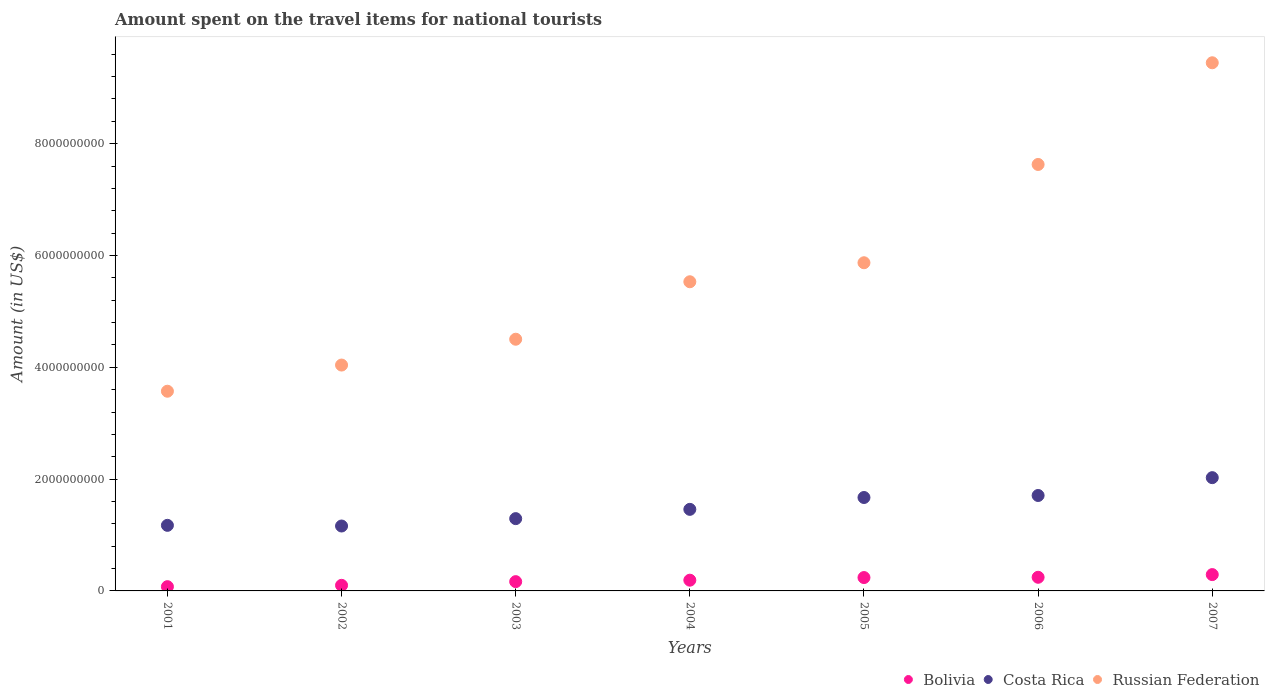Is the number of dotlines equal to the number of legend labels?
Your response must be concise. Yes. What is the amount spent on the travel items for national tourists in Costa Rica in 2004?
Ensure brevity in your answer.  1.46e+09. Across all years, what is the maximum amount spent on the travel items for national tourists in Bolivia?
Give a very brief answer. 2.92e+08. Across all years, what is the minimum amount spent on the travel items for national tourists in Costa Rica?
Give a very brief answer. 1.16e+09. In which year was the amount spent on the travel items for national tourists in Bolivia maximum?
Ensure brevity in your answer.  2007. What is the total amount spent on the travel items for national tourists in Bolivia in the graph?
Your answer should be compact. 1.31e+09. What is the difference between the amount spent on the travel items for national tourists in Russian Federation in 2003 and that in 2007?
Your answer should be compact. -4.94e+09. What is the difference between the amount spent on the travel items for national tourists in Bolivia in 2004 and the amount spent on the travel items for national tourists in Costa Rica in 2003?
Keep it short and to the point. -1.10e+09. What is the average amount spent on the travel items for national tourists in Bolivia per year?
Your answer should be compact. 1.87e+08. In the year 2004, what is the difference between the amount spent on the travel items for national tourists in Russian Federation and amount spent on the travel items for national tourists in Costa Rica?
Your response must be concise. 4.07e+09. What is the ratio of the amount spent on the travel items for national tourists in Russian Federation in 2001 to that in 2007?
Offer a very short reply. 0.38. Is the difference between the amount spent on the travel items for national tourists in Russian Federation in 2004 and 2007 greater than the difference between the amount spent on the travel items for national tourists in Costa Rica in 2004 and 2007?
Give a very brief answer. No. What is the difference between the highest and the second highest amount spent on the travel items for national tourists in Russian Federation?
Offer a very short reply. 1.82e+09. What is the difference between the highest and the lowest amount spent on the travel items for national tourists in Bolivia?
Your answer should be very brief. 2.16e+08. In how many years, is the amount spent on the travel items for national tourists in Bolivia greater than the average amount spent on the travel items for national tourists in Bolivia taken over all years?
Offer a very short reply. 4. Does the amount spent on the travel items for national tourists in Russian Federation monotonically increase over the years?
Make the answer very short. Yes. Is the amount spent on the travel items for national tourists in Russian Federation strictly greater than the amount spent on the travel items for national tourists in Costa Rica over the years?
Make the answer very short. Yes. How many years are there in the graph?
Ensure brevity in your answer.  7. Where does the legend appear in the graph?
Provide a succinct answer. Bottom right. How many legend labels are there?
Offer a terse response. 3. What is the title of the graph?
Provide a short and direct response. Amount spent on the travel items for national tourists. What is the label or title of the X-axis?
Provide a short and direct response. Years. What is the label or title of the Y-axis?
Your answer should be very brief. Amount (in US$). What is the Amount (in US$) in Bolivia in 2001?
Ensure brevity in your answer.  7.60e+07. What is the Amount (in US$) of Costa Rica in 2001?
Offer a terse response. 1.17e+09. What is the Amount (in US$) in Russian Federation in 2001?
Offer a terse response. 3.57e+09. What is the Amount (in US$) of Costa Rica in 2002?
Provide a succinct answer. 1.16e+09. What is the Amount (in US$) of Russian Federation in 2002?
Provide a short and direct response. 4.04e+09. What is the Amount (in US$) of Bolivia in 2003?
Offer a terse response. 1.66e+08. What is the Amount (in US$) of Costa Rica in 2003?
Your answer should be very brief. 1.29e+09. What is the Amount (in US$) in Russian Federation in 2003?
Offer a very short reply. 4.50e+09. What is the Amount (in US$) in Bolivia in 2004?
Ensure brevity in your answer.  1.92e+08. What is the Amount (in US$) of Costa Rica in 2004?
Offer a terse response. 1.46e+09. What is the Amount (in US$) of Russian Federation in 2004?
Ensure brevity in your answer.  5.53e+09. What is the Amount (in US$) in Bolivia in 2005?
Keep it short and to the point. 2.39e+08. What is the Amount (in US$) of Costa Rica in 2005?
Ensure brevity in your answer.  1.67e+09. What is the Amount (in US$) of Russian Federation in 2005?
Keep it short and to the point. 5.87e+09. What is the Amount (in US$) of Bolivia in 2006?
Offer a terse response. 2.44e+08. What is the Amount (in US$) of Costa Rica in 2006?
Offer a terse response. 1.71e+09. What is the Amount (in US$) in Russian Federation in 2006?
Give a very brief answer. 7.63e+09. What is the Amount (in US$) in Bolivia in 2007?
Your response must be concise. 2.92e+08. What is the Amount (in US$) of Costa Rica in 2007?
Offer a terse response. 2.03e+09. What is the Amount (in US$) of Russian Federation in 2007?
Your answer should be compact. 9.45e+09. Across all years, what is the maximum Amount (in US$) in Bolivia?
Make the answer very short. 2.92e+08. Across all years, what is the maximum Amount (in US$) of Costa Rica?
Provide a short and direct response. 2.03e+09. Across all years, what is the maximum Amount (in US$) of Russian Federation?
Make the answer very short. 9.45e+09. Across all years, what is the minimum Amount (in US$) of Bolivia?
Offer a terse response. 7.60e+07. Across all years, what is the minimum Amount (in US$) in Costa Rica?
Ensure brevity in your answer.  1.16e+09. Across all years, what is the minimum Amount (in US$) in Russian Federation?
Your answer should be very brief. 3.57e+09. What is the total Amount (in US$) in Bolivia in the graph?
Your response must be concise. 1.31e+09. What is the total Amount (in US$) of Costa Rica in the graph?
Keep it short and to the point. 1.05e+1. What is the total Amount (in US$) of Russian Federation in the graph?
Your answer should be compact. 4.06e+1. What is the difference between the Amount (in US$) in Bolivia in 2001 and that in 2002?
Provide a succinct answer. -2.40e+07. What is the difference between the Amount (in US$) in Russian Federation in 2001 and that in 2002?
Your answer should be very brief. -4.68e+08. What is the difference between the Amount (in US$) in Bolivia in 2001 and that in 2003?
Keep it short and to the point. -9.00e+07. What is the difference between the Amount (in US$) in Costa Rica in 2001 and that in 2003?
Your answer should be compact. -1.20e+08. What is the difference between the Amount (in US$) of Russian Federation in 2001 and that in 2003?
Ensure brevity in your answer.  -9.30e+08. What is the difference between the Amount (in US$) of Bolivia in 2001 and that in 2004?
Offer a very short reply. -1.16e+08. What is the difference between the Amount (in US$) of Costa Rica in 2001 and that in 2004?
Make the answer very short. -2.86e+08. What is the difference between the Amount (in US$) in Russian Federation in 2001 and that in 2004?
Give a very brief answer. -1.96e+09. What is the difference between the Amount (in US$) in Bolivia in 2001 and that in 2005?
Provide a short and direct response. -1.63e+08. What is the difference between the Amount (in US$) of Costa Rica in 2001 and that in 2005?
Give a very brief answer. -4.98e+08. What is the difference between the Amount (in US$) of Russian Federation in 2001 and that in 2005?
Ensure brevity in your answer.  -2.30e+09. What is the difference between the Amount (in US$) in Bolivia in 2001 and that in 2006?
Offer a terse response. -1.68e+08. What is the difference between the Amount (in US$) in Costa Rica in 2001 and that in 2006?
Your answer should be very brief. -5.34e+08. What is the difference between the Amount (in US$) in Russian Federation in 2001 and that in 2006?
Make the answer very short. -4.06e+09. What is the difference between the Amount (in US$) of Bolivia in 2001 and that in 2007?
Provide a short and direct response. -2.16e+08. What is the difference between the Amount (in US$) in Costa Rica in 2001 and that in 2007?
Offer a very short reply. -8.53e+08. What is the difference between the Amount (in US$) of Russian Federation in 2001 and that in 2007?
Provide a succinct answer. -5.88e+09. What is the difference between the Amount (in US$) in Bolivia in 2002 and that in 2003?
Make the answer very short. -6.60e+07. What is the difference between the Amount (in US$) in Costa Rica in 2002 and that in 2003?
Provide a succinct answer. -1.32e+08. What is the difference between the Amount (in US$) of Russian Federation in 2002 and that in 2003?
Your response must be concise. -4.62e+08. What is the difference between the Amount (in US$) of Bolivia in 2002 and that in 2004?
Your answer should be very brief. -9.20e+07. What is the difference between the Amount (in US$) in Costa Rica in 2002 and that in 2004?
Ensure brevity in your answer.  -2.98e+08. What is the difference between the Amount (in US$) of Russian Federation in 2002 and that in 2004?
Keep it short and to the point. -1.49e+09. What is the difference between the Amount (in US$) of Bolivia in 2002 and that in 2005?
Keep it short and to the point. -1.39e+08. What is the difference between the Amount (in US$) in Costa Rica in 2002 and that in 2005?
Offer a terse response. -5.10e+08. What is the difference between the Amount (in US$) in Russian Federation in 2002 and that in 2005?
Your answer should be compact. -1.83e+09. What is the difference between the Amount (in US$) in Bolivia in 2002 and that in 2006?
Your response must be concise. -1.44e+08. What is the difference between the Amount (in US$) of Costa Rica in 2002 and that in 2006?
Provide a succinct answer. -5.46e+08. What is the difference between the Amount (in US$) of Russian Federation in 2002 and that in 2006?
Make the answer very short. -3.59e+09. What is the difference between the Amount (in US$) of Bolivia in 2002 and that in 2007?
Provide a short and direct response. -1.92e+08. What is the difference between the Amount (in US$) in Costa Rica in 2002 and that in 2007?
Offer a very short reply. -8.65e+08. What is the difference between the Amount (in US$) of Russian Federation in 2002 and that in 2007?
Ensure brevity in your answer.  -5.41e+09. What is the difference between the Amount (in US$) of Bolivia in 2003 and that in 2004?
Provide a succinct answer. -2.60e+07. What is the difference between the Amount (in US$) in Costa Rica in 2003 and that in 2004?
Your answer should be very brief. -1.66e+08. What is the difference between the Amount (in US$) in Russian Federation in 2003 and that in 2004?
Offer a very short reply. -1.03e+09. What is the difference between the Amount (in US$) of Bolivia in 2003 and that in 2005?
Your answer should be compact. -7.30e+07. What is the difference between the Amount (in US$) in Costa Rica in 2003 and that in 2005?
Keep it short and to the point. -3.78e+08. What is the difference between the Amount (in US$) of Russian Federation in 2003 and that in 2005?
Give a very brief answer. -1.37e+09. What is the difference between the Amount (in US$) of Bolivia in 2003 and that in 2006?
Your answer should be compact. -7.80e+07. What is the difference between the Amount (in US$) of Costa Rica in 2003 and that in 2006?
Offer a terse response. -4.14e+08. What is the difference between the Amount (in US$) in Russian Federation in 2003 and that in 2006?
Make the answer very short. -3.13e+09. What is the difference between the Amount (in US$) of Bolivia in 2003 and that in 2007?
Offer a very short reply. -1.26e+08. What is the difference between the Amount (in US$) in Costa Rica in 2003 and that in 2007?
Give a very brief answer. -7.33e+08. What is the difference between the Amount (in US$) in Russian Federation in 2003 and that in 2007?
Your response must be concise. -4.94e+09. What is the difference between the Amount (in US$) of Bolivia in 2004 and that in 2005?
Ensure brevity in your answer.  -4.70e+07. What is the difference between the Amount (in US$) of Costa Rica in 2004 and that in 2005?
Provide a succinct answer. -2.12e+08. What is the difference between the Amount (in US$) in Russian Federation in 2004 and that in 2005?
Keep it short and to the point. -3.40e+08. What is the difference between the Amount (in US$) in Bolivia in 2004 and that in 2006?
Your answer should be very brief. -5.20e+07. What is the difference between the Amount (in US$) of Costa Rica in 2004 and that in 2006?
Provide a succinct answer. -2.48e+08. What is the difference between the Amount (in US$) of Russian Federation in 2004 and that in 2006?
Keep it short and to the point. -2.10e+09. What is the difference between the Amount (in US$) in Bolivia in 2004 and that in 2007?
Provide a succinct answer. -1.00e+08. What is the difference between the Amount (in US$) of Costa Rica in 2004 and that in 2007?
Your response must be concise. -5.67e+08. What is the difference between the Amount (in US$) of Russian Federation in 2004 and that in 2007?
Give a very brief answer. -3.92e+09. What is the difference between the Amount (in US$) in Bolivia in 2005 and that in 2006?
Offer a terse response. -5.00e+06. What is the difference between the Amount (in US$) of Costa Rica in 2005 and that in 2006?
Provide a succinct answer. -3.60e+07. What is the difference between the Amount (in US$) of Russian Federation in 2005 and that in 2006?
Keep it short and to the point. -1.76e+09. What is the difference between the Amount (in US$) of Bolivia in 2005 and that in 2007?
Ensure brevity in your answer.  -5.30e+07. What is the difference between the Amount (in US$) in Costa Rica in 2005 and that in 2007?
Ensure brevity in your answer.  -3.55e+08. What is the difference between the Amount (in US$) in Russian Federation in 2005 and that in 2007?
Your answer should be very brief. -3.58e+09. What is the difference between the Amount (in US$) in Bolivia in 2006 and that in 2007?
Ensure brevity in your answer.  -4.80e+07. What is the difference between the Amount (in US$) of Costa Rica in 2006 and that in 2007?
Provide a short and direct response. -3.19e+08. What is the difference between the Amount (in US$) in Russian Federation in 2006 and that in 2007?
Give a very brief answer. -1.82e+09. What is the difference between the Amount (in US$) of Bolivia in 2001 and the Amount (in US$) of Costa Rica in 2002?
Keep it short and to the point. -1.08e+09. What is the difference between the Amount (in US$) in Bolivia in 2001 and the Amount (in US$) in Russian Federation in 2002?
Offer a very short reply. -3.96e+09. What is the difference between the Amount (in US$) in Costa Rica in 2001 and the Amount (in US$) in Russian Federation in 2002?
Your answer should be compact. -2.87e+09. What is the difference between the Amount (in US$) of Bolivia in 2001 and the Amount (in US$) of Costa Rica in 2003?
Your answer should be compact. -1.22e+09. What is the difference between the Amount (in US$) of Bolivia in 2001 and the Amount (in US$) of Russian Federation in 2003?
Offer a terse response. -4.43e+09. What is the difference between the Amount (in US$) of Costa Rica in 2001 and the Amount (in US$) of Russian Federation in 2003?
Make the answer very short. -3.33e+09. What is the difference between the Amount (in US$) of Bolivia in 2001 and the Amount (in US$) of Costa Rica in 2004?
Provide a short and direct response. -1.38e+09. What is the difference between the Amount (in US$) in Bolivia in 2001 and the Amount (in US$) in Russian Federation in 2004?
Offer a very short reply. -5.45e+09. What is the difference between the Amount (in US$) in Costa Rica in 2001 and the Amount (in US$) in Russian Federation in 2004?
Offer a very short reply. -4.36e+09. What is the difference between the Amount (in US$) in Bolivia in 2001 and the Amount (in US$) in Costa Rica in 2005?
Give a very brief answer. -1.60e+09. What is the difference between the Amount (in US$) of Bolivia in 2001 and the Amount (in US$) of Russian Federation in 2005?
Ensure brevity in your answer.  -5.79e+09. What is the difference between the Amount (in US$) in Costa Rica in 2001 and the Amount (in US$) in Russian Federation in 2005?
Your answer should be compact. -4.70e+09. What is the difference between the Amount (in US$) of Bolivia in 2001 and the Amount (in US$) of Costa Rica in 2006?
Make the answer very short. -1.63e+09. What is the difference between the Amount (in US$) in Bolivia in 2001 and the Amount (in US$) in Russian Federation in 2006?
Give a very brief answer. -7.55e+09. What is the difference between the Amount (in US$) of Costa Rica in 2001 and the Amount (in US$) of Russian Federation in 2006?
Give a very brief answer. -6.46e+09. What is the difference between the Amount (in US$) of Bolivia in 2001 and the Amount (in US$) of Costa Rica in 2007?
Offer a terse response. -1.95e+09. What is the difference between the Amount (in US$) in Bolivia in 2001 and the Amount (in US$) in Russian Federation in 2007?
Make the answer very short. -9.37e+09. What is the difference between the Amount (in US$) of Costa Rica in 2001 and the Amount (in US$) of Russian Federation in 2007?
Give a very brief answer. -8.27e+09. What is the difference between the Amount (in US$) of Bolivia in 2002 and the Amount (in US$) of Costa Rica in 2003?
Give a very brief answer. -1.19e+09. What is the difference between the Amount (in US$) in Bolivia in 2002 and the Amount (in US$) in Russian Federation in 2003?
Give a very brief answer. -4.40e+09. What is the difference between the Amount (in US$) in Costa Rica in 2002 and the Amount (in US$) in Russian Federation in 2003?
Offer a terse response. -3.34e+09. What is the difference between the Amount (in US$) in Bolivia in 2002 and the Amount (in US$) in Costa Rica in 2004?
Offer a very short reply. -1.36e+09. What is the difference between the Amount (in US$) in Bolivia in 2002 and the Amount (in US$) in Russian Federation in 2004?
Ensure brevity in your answer.  -5.43e+09. What is the difference between the Amount (in US$) in Costa Rica in 2002 and the Amount (in US$) in Russian Federation in 2004?
Keep it short and to the point. -4.37e+09. What is the difference between the Amount (in US$) in Bolivia in 2002 and the Amount (in US$) in Costa Rica in 2005?
Your answer should be compact. -1.57e+09. What is the difference between the Amount (in US$) in Bolivia in 2002 and the Amount (in US$) in Russian Federation in 2005?
Your response must be concise. -5.77e+09. What is the difference between the Amount (in US$) of Costa Rica in 2002 and the Amount (in US$) of Russian Federation in 2005?
Provide a succinct answer. -4.71e+09. What is the difference between the Amount (in US$) of Bolivia in 2002 and the Amount (in US$) of Costa Rica in 2006?
Your response must be concise. -1.61e+09. What is the difference between the Amount (in US$) in Bolivia in 2002 and the Amount (in US$) in Russian Federation in 2006?
Provide a succinct answer. -7.53e+09. What is the difference between the Amount (in US$) of Costa Rica in 2002 and the Amount (in US$) of Russian Federation in 2006?
Make the answer very short. -6.47e+09. What is the difference between the Amount (in US$) in Bolivia in 2002 and the Amount (in US$) in Costa Rica in 2007?
Your response must be concise. -1.93e+09. What is the difference between the Amount (in US$) of Bolivia in 2002 and the Amount (in US$) of Russian Federation in 2007?
Your answer should be very brief. -9.35e+09. What is the difference between the Amount (in US$) in Costa Rica in 2002 and the Amount (in US$) in Russian Federation in 2007?
Your answer should be very brief. -8.29e+09. What is the difference between the Amount (in US$) in Bolivia in 2003 and the Amount (in US$) in Costa Rica in 2004?
Your answer should be very brief. -1.29e+09. What is the difference between the Amount (in US$) of Bolivia in 2003 and the Amount (in US$) of Russian Federation in 2004?
Offer a very short reply. -5.36e+09. What is the difference between the Amount (in US$) in Costa Rica in 2003 and the Amount (in US$) in Russian Federation in 2004?
Provide a succinct answer. -4.24e+09. What is the difference between the Amount (in US$) in Bolivia in 2003 and the Amount (in US$) in Costa Rica in 2005?
Your answer should be very brief. -1.50e+09. What is the difference between the Amount (in US$) of Bolivia in 2003 and the Amount (in US$) of Russian Federation in 2005?
Provide a succinct answer. -5.70e+09. What is the difference between the Amount (in US$) of Costa Rica in 2003 and the Amount (in US$) of Russian Federation in 2005?
Give a very brief answer. -4.58e+09. What is the difference between the Amount (in US$) of Bolivia in 2003 and the Amount (in US$) of Costa Rica in 2006?
Give a very brief answer. -1.54e+09. What is the difference between the Amount (in US$) of Bolivia in 2003 and the Amount (in US$) of Russian Federation in 2006?
Give a very brief answer. -7.46e+09. What is the difference between the Amount (in US$) of Costa Rica in 2003 and the Amount (in US$) of Russian Federation in 2006?
Your response must be concise. -6.34e+09. What is the difference between the Amount (in US$) of Bolivia in 2003 and the Amount (in US$) of Costa Rica in 2007?
Provide a succinct answer. -1.86e+09. What is the difference between the Amount (in US$) of Bolivia in 2003 and the Amount (in US$) of Russian Federation in 2007?
Provide a short and direct response. -9.28e+09. What is the difference between the Amount (in US$) of Costa Rica in 2003 and the Amount (in US$) of Russian Federation in 2007?
Your response must be concise. -8.15e+09. What is the difference between the Amount (in US$) of Bolivia in 2004 and the Amount (in US$) of Costa Rica in 2005?
Make the answer very short. -1.48e+09. What is the difference between the Amount (in US$) in Bolivia in 2004 and the Amount (in US$) in Russian Federation in 2005?
Your answer should be very brief. -5.68e+09. What is the difference between the Amount (in US$) in Costa Rica in 2004 and the Amount (in US$) in Russian Federation in 2005?
Your answer should be very brief. -4.41e+09. What is the difference between the Amount (in US$) of Bolivia in 2004 and the Amount (in US$) of Costa Rica in 2006?
Offer a very short reply. -1.52e+09. What is the difference between the Amount (in US$) in Bolivia in 2004 and the Amount (in US$) in Russian Federation in 2006?
Provide a succinct answer. -7.44e+09. What is the difference between the Amount (in US$) in Costa Rica in 2004 and the Amount (in US$) in Russian Federation in 2006?
Your answer should be very brief. -6.17e+09. What is the difference between the Amount (in US$) in Bolivia in 2004 and the Amount (in US$) in Costa Rica in 2007?
Keep it short and to the point. -1.83e+09. What is the difference between the Amount (in US$) of Bolivia in 2004 and the Amount (in US$) of Russian Federation in 2007?
Keep it short and to the point. -9.26e+09. What is the difference between the Amount (in US$) of Costa Rica in 2004 and the Amount (in US$) of Russian Federation in 2007?
Offer a very short reply. -7.99e+09. What is the difference between the Amount (in US$) of Bolivia in 2005 and the Amount (in US$) of Costa Rica in 2006?
Provide a short and direct response. -1.47e+09. What is the difference between the Amount (in US$) in Bolivia in 2005 and the Amount (in US$) in Russian Federation in 2006?
Give a very brief answer. -7.39e+09. What is the difference between the Amount (in US$) in Costa Rica in 2005 and the Amount (in US$) in Russian Federation in 2006?
Make the answer very short. -5.96e+09. What is the difference between the Amount (in US$) in Bolivia in 2005 and the Amount (in US$) in Costa Rica in 2007?
Your response must be concise. -1.79e+09. What is the difference between the Amount (in US$) in Bolivia in 2005 and the Amount (in US$) in Russian Federation in 2007?
Make the answer very short. -9.21e+09. What is the difference between the Amount (in US$) in Costa Rica in 2005 and the Amount (in US$) in Russian Federation in 2007?
Provide a short and direct response. -7.78e+09. What is the difference between the Amount (in US$) in Bolivia in 2006 and the Amount (in US$) in Costa Rica in 2007?
Ensure brevity in your answer.  -1.78e+09. What is the difference between the Amount (in US$) of Bolivia in 2006 and the Amount (in US$) of Russian Federation in 2007?
Provide a short and direct response. -9.20e+09. What is the difference between the Amount (in US$) of Costa Rica in 2006 and the Amount (in US$) of Russian Federation in 2007?
Your answer should be compact. -7.74e+09. What is the average Amount (in US$) in Bolivia per year?
Your response must be concise. 1.87e+08. What is the average Amount (in US$) of Costa Rica per year?
Offer a terse response. 1.50e+09. What is the average Amount (in US$) of Russian Federation per year?
Your answer should be very brief. 5.80e+09. In the year 2001, what is the difference between the Amount (in US$) of Bolivia and Amount (in US$) of Costa Rica?
Your answer should be compact. -1.10e+09. In the year 2001, what is the difference between the Amount (in US$) in Bolivia and Amount (in US$) in Russian Federation?
Provide a short and direct response. -3.50e+09. In the year 2001, what is the difference between the Amount (in US$) of Costa Rica and Amount (in US$) of Russian Federation?
Keep it short and to the point. -2.40e+09. In the year 2002, what is the difference between the Amount (in US$) of Bolivia and Amount (in US$) of Costa Rica?
Your response must be concise. -1.06e+09. In the year 2002, what is the difference between the Amount (in US$) in Bolivia and Amount (in US$) in Russian Federation?
Offer a terse response. -3.94e+09. In the year 2002, what is the difference between the Amount (in US$) of Costa Rica and Amount (in US$) of Russian Federation?
Your response must be concise. -2.88e+09. In the year 2003, what is the difference between the Amount (in US$) of Bolivia and Amount (in US$) of Costa Rica?
Make the answer very short. -1.13e+09. In the year 2003, what is the difference between the Amount (in US$) in Bolivia and Amount (in US$) in Russian Federation?
Your response must be concise. -4.34e+09. In the year 2003, what is the difference between the Amount (in US$) of Costa Rica and Amount (in US$) of Russian Federation?
Your response must be concise. -3.21e+09. In the year 2004, what is the difference between the Amount (in US$) in Bolivia and Amount (in US$) in Costa Rica?
Offer a very short reply. -1.27e+09. In the year 2004, what is the difference between the Amount (in US$) of Bolivia and Amount (in US$) of Russian Federation?
Your answer should be compact. -5.34e+09. In the year 2004, what is the difference between the Amount (in US$) in Costa Rica and Amount (in US$) in Russian Federation?
Make the answer very short. -4.07e+09. In the year 2005, what is the difference between the Amount (in US$) in Bolivia and Amount (in US$) in Costa Rica?
Give a very brief answer. -1.43e+09. In the year 2005, what is the difference between the Amount (in US$) in Bolivia and Amount (in US$) in Russian Federation?
Provide a succinct answer. -5.63e+09. In the year 2005, what is the difference between the Amount (in US$) of Costa Rica and Amount (in US$) of Russian Federation?
Provide a succinct answer. -4.20e+09. In the year 2006, what is the difference between the Amount (in US$) of Bolivia and Amount (in US$) of Costa Rica?
Give a very brief answer. -1.46e+09. In the year 2006, what is the difference between the Amount (in US$) of Bolivia and Amount (in US$) of Russian Federation?
Keep it short and to the point. -7.38e+09. In the year 2006, what is the difference between the Amount (in US$) in Costa Rica and Amount (in US$) in Russian Federation?
Make the answer very short. -5.92e+09. In the year 2007, what is the difference between the Amount (in US$) in Bolivia and Amount (in US$) in Costa Rica?
Ensure brevity in your answer.  -1.73e+09. In the year 2007, what is the difference between the Amount (in US$) in Bolivia and Amount (in US$) in Russian Federation?
Make the answer very short. -9.16e+09. In the year 2007, what is the difference between the Amount (in US$) in Costa Rica and Amount (in US$) in Russian Federation?
Make the answer very short. -7.42e+09. What is the ratio of the Amount (in US$) of Bolivia in 2001 to that in 2002?
Offer a terse response. 0.76. What is the ratio of the Amount (in US$) in Costa Rica in 2001 to that in 2002?
Provide a succinct answer. 1.01. What is the ratio of the Amount (in US$) in Russian Federation in 2001 to that in 2002?
Provide a succinct answer. 0.88. What is the ratio of the Amount (in US$) in Bolivia in 2001 to that in 2003?
Provide a short and direct response. 0.46. What is the ratio of the Amount (in US$) in Costa Rica in 2001 to that in 2003?
Offer a terse response. 0.91. What is the ratio of the Amount (in US$) in Russian Federation in 2001 to that in 2003?
Your answer should be very brief. 0.79. What is the ratio of the Amount (in US$) of Bolivia in 2001 to that in 2004?
Offer a terse response. 0.4. What is the ratio of the Amount (in US$) of Costa Rica in 2001 to that in 2004?
Your answer should be very brief. 0.8. What is the ratio of the Amount (in US$) in Russian Federation in 2001 to that in 2004?
Offer a very short reply. 0.65. What is the ratio of the Amount (in US$) in Bolivia in 2001 to that in 2005?
Your response must be concise. 0.32. What is the ratio of the Amount (in US$) in Costa Rica in 2001 to that in 2005?
Provide a succinct answer. 0.7. What is the ratio of the Amount (in US$) of Russian Federation in 2001 to that in 2005?
Your answer should be very brief. 0.61. What is the ratio of the Amount (in US$) in Bolivia in 2001 to that in 2006?
Make the answer very short. 0.31. What is the ratio of the Amount (in US$) in Costa Rica in 2001 to that in 2006?
Offer a very short reply. 0.69. What is the ratio of the Amount (in US$) in Russian Federation in 2001 to that in 2006?
Make the answer very short. 0.47. What is the ratio of the Amount (in US$) in Bolivia in 2001 to that in 2007?
Your answer should be very brief. 0.26. What is the ratio of the Amount (in US$) in Costa Rica in 2001 to that in 2007?
Ensure brevity in your answer.  0.58. What is the ratio of the Amount (in US$) of Russian Federation in 2001 to that in 2007?
Offer a very short reply. 0.38. What is the ratio of the Amount (in US$) in Bolivia in 2002 to that in 2003?
Your response must be concise. 0.6. What is the ratio of the Amount (in US$) in Costa Rica in 2002 to that in 2003?
Offer a very short reply. 0.9. What is the ratio of the Amount (in US$) in Russian Federation in 2002 to that in 2003?
Ensure brevity in your answer.  0.9. What is the ratio of the Amount (in US$) in Bolivia in 2002 to that in 2004?
Provide a succinct answer. 0.52. What is the ratio of the Amount (in US$) in Costa Rica in 2002 to that in 2004?
Your response must be concise. 0.8. What is the ratio of the Amount (in US$) in Russian Federation in 2002 to that in 2004?
Make the answer very short. 0.73. What is the ratio of the Amount (in US$) of Bolivia in 2002 to that in 2005?
Ensure brevity in your answer.  0.42. What is the ratio of the Amount (in US$) in Costa Rica in 2002 to that in 2005?
Your response must be concise. 0.69. What is the ratio of the Amount (in US$) of Russian Federation in 2002 to that in 2005?
Your answer should be compact. 0.69. What is the ratio of the Amount (in US$) of Bolivia in 2002 to that in 2006?
Offer a terse response. 0.41. What is the ratio of the Amount (in US$) of Costa Rica in 2002 to that in 2006?
Your response must be concise. 0.68. What is the ratio of the Amount (in US$) in Russian Federation in 2002 to that in 2006?
Your answer should be very brief. 0.53. What is the ratio of the Amount (in US$) in Bolivia in 2002 to that in 2007?
Provide a short and direct response. 0.34. What is the ratio of the Amount (in US$) in Costa Rica in 2002 to that in 2007?
Make the answer very short. 0.57. What is the ratio of the Amount (in US$) in Russian Federation in 2002 to that in 2007?
Your answer should be compact. 0.43. What is the ratio of the Amount (in US$) in Bolivia in 2003 to that in 2004?
Give a very brief answer. 0.86. What is the ratio of the Amount (in US$) in Costa Rica in 2003 to that in 2004?
Offer a terse response. 0.89. What is the ratio of the Amount (in US$) in Russian Federation in 2003 to that in 2004?
Ensure brevity in your answer.  0.81. What is the ratio of the Amount (in US$) in Bolivia in 2003 to that in 2005?
Provide a short and direct response. 0.69. What is the ratio of the Amount (in US$) of Costa Rica in 2003 to that in 2005?
Ensure brevity in your answer.  0.77. What is the ratio of the Amount (in US$) of Russian Federation in 2003 to that in 2005?
Your answer should be compact. 0.77. What is the ratio of the Amount (in US$) in Bolivia in 2003 to that in 2006?
Ensure brevity in your answer.  0.68. What is the ratio of the Amount (in US$) of Costa Rica in 2003 to that in 2006?
Make the answer very short. 0.76. What is the ratio of the Amount (in US$) of Russian Federation in 2003 to that in 2006?
Provide a short and direct response. 0.59. What is the ratio of the Amount (in US$) of Bolivia in 2003 to that in 2007?
Provide a succinct answer. 0.57. What is the ratio of the Amount (in US$) in Costa Rica in 2003 to that in 2007?
Your response must be concise. 0.64. What is the ratio of the Amount (in US$) of Russian Federation in 2003 to that in 2007?
Your answer should be compact. 0.48. What is the ratio of the Amount (in US$) of Bolivia in 2004 to that in 2005?
Provide a succinct answer. 0.8. What is the ratio of the Amount (in US$) of Costa Rica in 2004 to that in 2005?
Keep it short and to the point. 0.87. What is the ratio of the Amount (in US$) in Russian Federation in 2004 to that in 2005?
Your response must be concise. 0.94. What is the ratio of the Amount (in US$) of Bolivia in 2004 to that in 2006?
Your answer should be compact. 0.79. What is the ratio of the Amount (in US$) in Costa Rica in 2004 to that in 2006?
Make the answer very short. 0.85. What is the ratio of the Amount (in US$) in Russian Federation in 2004 to that in 2006?
Offer a very short reply. 0.72. What is the ratio of the Amount (in US$) of Bolivia in 2004 to that in 2007?
Your response must be concise. 0.66. What is the ratio of the Amount (in US$) of Costa Rica in 2004 to that in 2007?
Your response must be concise. 0.72. What is the ratio of the Amount (in US$) in Russian Federation in 2004 to that in 2007?
Ensure brevity in your answer.  0.59. What is the ratio of the Amount (in US$) of Bolivia in 2005 to that in 2006?
Your answer should be very brief. 0.98. What is the ratio of the Amount (in US$) of Costa Rica in 2005 to that in 2006?
Your answer should be compact. 0.98. What is the ratio of the Amount (in US$) of Russian Federation in 2005 to that in 2006?
Give a very brief answer. 0.77. What is the ratio of the Amount (in US$) in Bolivia in 2005 to that in 2007?
Offer a very short reply. 0.82. What is the ratio of the Amount (in US$) of Costa Rica in 2005 to that in 2007?
Provide a succinct answer. 0.82. What is the ratio of the Amount (in US$) of Russian Federation in 2005 to that in 2007?
Your answer should be very brief. 0.62. What is the ratio of the Amount (in US$) in Bolivia in 2006 to that in 2007?
Your answer should be very brief. 0.84. What is the ratio of the Amount (in US$) of Costa Rica in 2006 to that in 2007?
Keep it short and to the point. 0.84. What is the ratio of the Amount (in US$) of Russian Federation in 2006 to that in 2007?
Make the answer very short. 0.81. What is the difference between the highest and the second highest Amount (in US$) of Bolivia?
Give a very brief answer. 4.80e+07. What is the difference between the highest and the second highest Amount (in US$) of Costa Rica?
Your answer should be very brief. 3.19e+08. What is the difference between the highest and the second highest Amount (in US$) of Russian Federation?
Offer a very short reply. 1.82e+09. What is the difference between the highest and the lowest Amount (in US$) of Bolivia?
Provide a short and direct response. 2.16e+08. What is the difference between the highest and the lowest Amount (in US$) in Costa Rica?
Provide a short and direct response. 8.65e+08. What is the difference between the highest and the lowest Amount (in US$) in Russian Federation?
Give a very brief answer. 5.88e+09. 